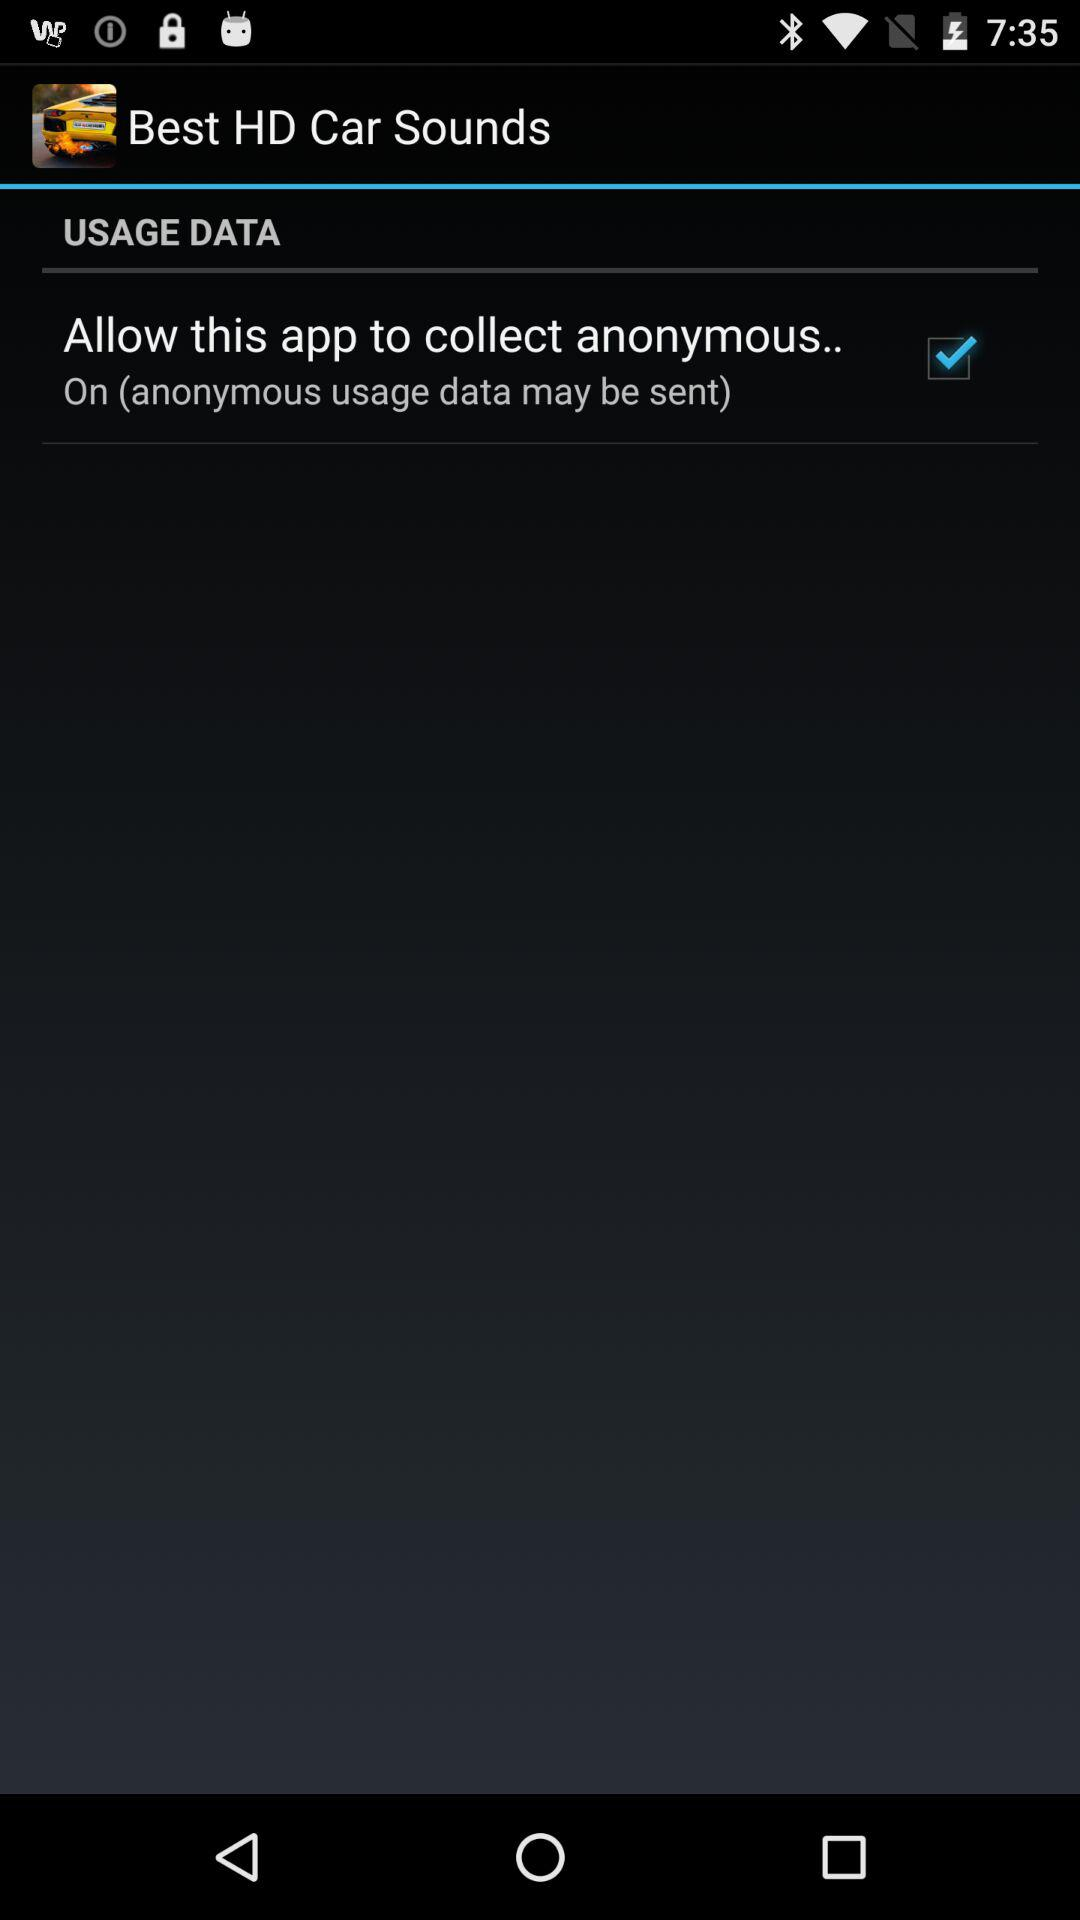What is the application name? The application name is "Best HD Car Sounds". 